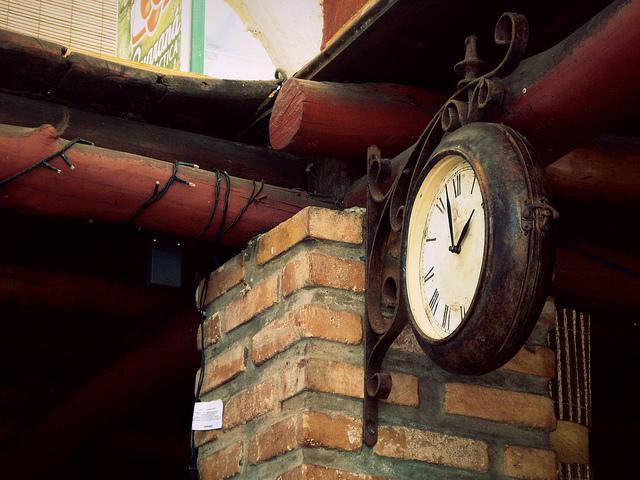How many of the baskets of food have forks in them?
Give a very brief answer. 0. 